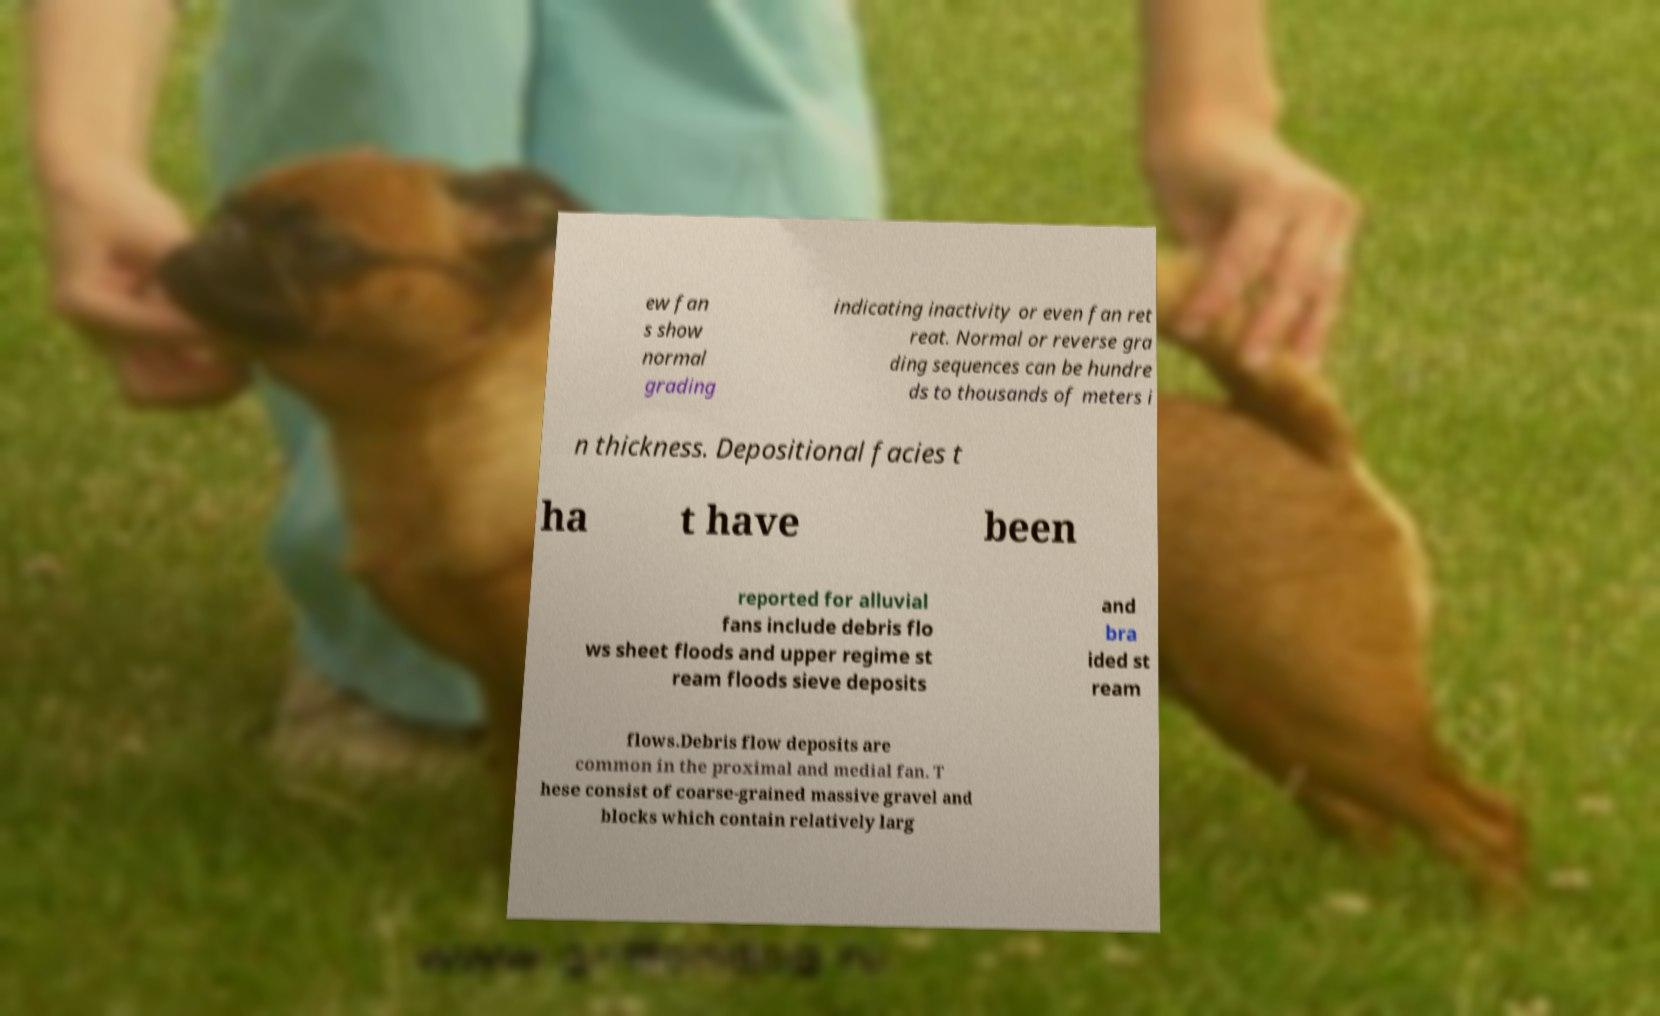There's text embedded in this image that I need extracted. Can you transcribe it verbatim? ew fan s show normal grading indicating inactivity or even fan ret reat. Normal or reverse gra ding sequences can be hundre ds to thousands of meters i n thickness. Depositional facies t ha t have been reported for alluvial fans include debris flo ws sheet floods and upper regime st ream floods sieve deposits and bra ided st ream flows.Debris flow deposits are common in the proximal and medial fan. T hese consist of coarse-grained massive gravel and blocks which contain relatively larg 